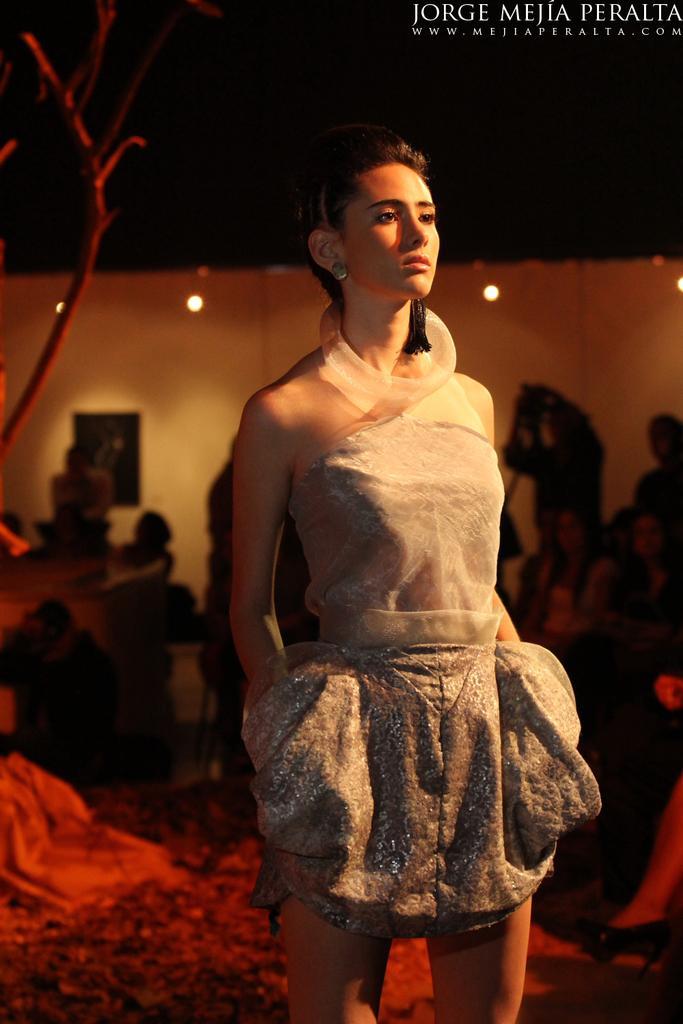Can you describe this image briefly? This image is taken indoors. At the bottom of the image there is a floor. In the middle of the image a woman is standing on the floor. In the background there are a few people and there is a wall with a few lights. 